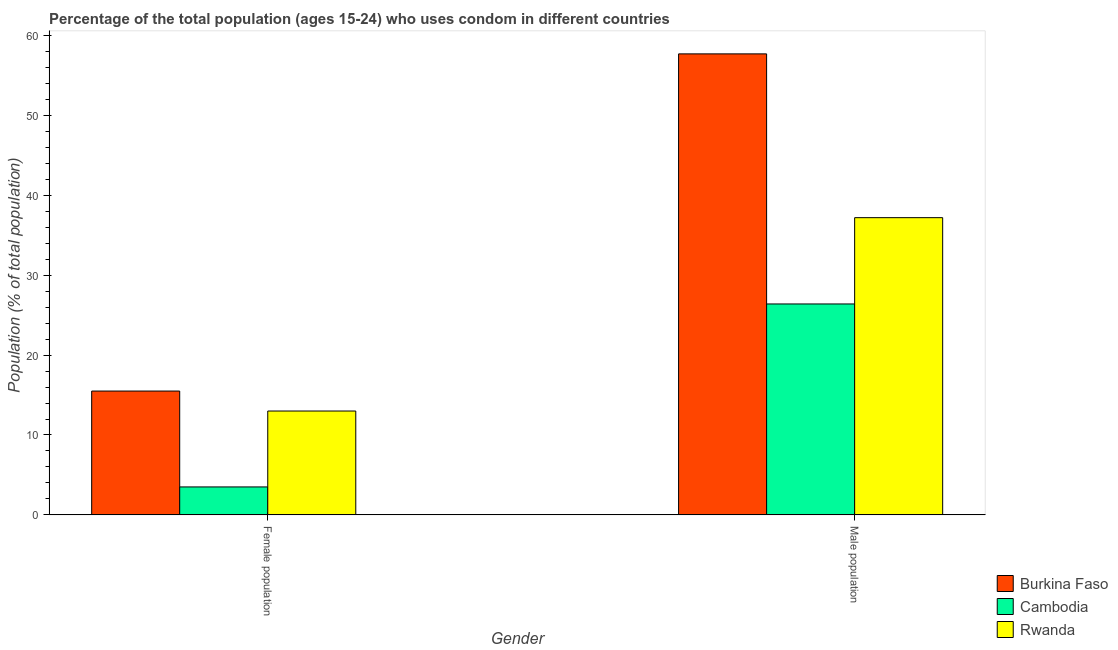How many different coloured bars are there?
Give a very brief answer. 3. How many groups of bars are there?
Provide a short and direct response. 2. Are the number of bars per tick equal to the number of legend labels?
Your response must be concise. Yes. How many bars are there on the 2nd tick from the left?
Your answer should be very brief. 3. What is the label of the 1st group of bars from the left?
Provide a succinct answer. Female population. What is the male population in Cambodia?
Provide a succinct answer. 26.4. Across all countries, what is the maximum male population?
Make the answer very short. 57.7. Across all countries, what is the minimum male population?
Ensure brevity in your answer.  26.4. In which country was the male population maximum?
Your answer should be very brief. Burkina Faso. In which country was the female population minimum?
Ensure brevity in your answer.  Cambodia. What is the total male population in the graph?
Offer a terse response. 121.3. What is the difference between the male population in Burkina Faso and that in Cambodia?
Your answer should be very brief. 31.3. What is the difference between the male population in Cambodia and the female population in Burkina Faso?
Your answer should be compact. 10.9. What is the average female population per country?
Give a very brief answer. 10.67. What is the difference between the female population and male population in Cambodia?
Give a very brief answer. -22.9. In how many countries, is the female population greater than 32 %?
Your answer should be very brief. 0. What is the ratio of the male population in Burkina Faso to that in Rwanda?
Keep it short and to the point. 1.55. In how many countries, is the male population greater than the average male population taken over all countries?
Give a very brief answer. 1. What does the 3rd bar from the left in Female population represents?
Keep it short and to the point. Rwanda. What does the 2nd bar from the right in Female population represents?
Give a very brief answer. Cambodia. How many bars are there?
Make the answer very short. 6. What is the difference between two consecutive major ticks on the Y-axis?
Offer a terse response. 10. Are the values on the major ticks of Y-axis written in scientific E-notation?
Your response must be concise. No. Where does the legend appear in the graph?
Offer a terse response. Bottom right. How are the legend labels stacked?
Make the answer very short. Vertical. What is the title of the graph?
Give a very brief answer. Percentage of the total population (ages 15-24) who uses condom in different countries. Does "Equatorial Guinea" appear as one of the legend labels in the graph?
Your answer should be very brief. No. What is the label or title of the X-axis?
Keep it short and to the point. Gender. What is the label or title of the Y-axis?
Provide a short and direct response. Population (% of total population) . What is the Population (% of total population)  in Burkina Faso in Male population?
Provide a succinct answer. 57.7. What is the Population (% of total population)  in Cambodia in Male population?
Ensure brevity in your answer.  26.4. What is the Population (% of total population)  in Rwanda in Male population?
Keep it short and to the point. 37.2. Across all Gender, what is the maximum Population (% of total population)  in Burkina Faso?
Give a very brief answer. 57.7. Across all Gender, what is the maximum Population (% of total population)  of Cambodia?
Make the answer very short. 26.4. Across all Gender, what is the maximum Population (% of total population)  in Rwanda?
Keep it short and to the point. 37.2. What is the total Population (% of total population)  in Burkina Faso in the graph?
Keep it short and to the point. 73.2. What is the total Population (% of total population)  in Cambodia in the graph?
Your answer should be very brief. 29.9. What is the total Population (% of total population)  of Rwanda in the graph?
Make the answer very short. 50.2. What is the difference between the Population (% of total population)  of Burkina Faso in Female population and that in Male population?
Keep it short and to the point. -42.2. What is the difference between the Population (% of total population)  in Cambodia in Female population and that in Male population?
Ensure brevity in your answer.  -22.9. What is the difference between the Population (% of total population)  of Rwanda in Female population and that in Male population?
Keep it short and to the point. -24.2. What is the difference between the Population (% of total population)  of Burkina Faso in Female population and the Population (% of total population)  of Cambodia in Male population?
Provide a short and direct response. -10.9. What is the difference between the Population (% of total population)  in Burkina Faso in Female population and the Population (% of total population)  in Rwanda in Male population?
Offer a terse response. -21.7. What is the difference between the Population (% of total population)  in Cambodia in Female population and the Population (% of total population)  in Rwanda in Male population?
Your response must be concise. -33.7. What is the average Population (% of total population)  of Burkina Faso per Gender?
Keep it short and to the point. 36.6. What is the average Population (% of total population)  in Cambodia per Gender?
Provide a succinct answer. 14.95. What is the average Population (% of total population)  in Rwanda per Gender?
Offer a very short reply. 25.1. What is the difference between the Population (% of total population)  of Burkina Faso and Population (% of total population)  of Rwanda in Female population?
Your response must be concise. 2.5. What is the difference between the Population (% of total population)  in Cambodia and Population (% of total population)  in Rwanda in Female population?
Provide a short and direct response. -9.5. What is the difference between the Population (% of total population)  of Burkina Faso and Population (% of total population)  of Cambodia in Male population?
Keep it short and to the point. 31.3. What is the ratio of the Population (% of total population)  in Burkina Faso in Female population to that in Male population?
Keep it short and to the point. 0.27. What is the ratio of the Population (% of total population)  in Cambodia in Female population to that in Male population?
Offer a very short reply. 0.13. What is the ratio of the Population (% of total population)  in Rwanda in Female population to that in Male population?
Offer a terse response. 0.35. What is the difference between the highest and the second highest Population (% of total population)  in Burkina Faso?
Your answer should be compact. 42.2. What is the difference between the highest and the second highest Population (% of total population)  of Cambodia?
Provide a succinct answer. 22.9. What is the difference between the highest and the second highest Population (% of total population)  in Rwanda?
Your response must be concise. 24.2. What is the difference between the highest and the lowest Population (% of total population)  in Burkina Faso?
Offer a very short reply. 42.2. What is the difference between the highest and the lowest Population (% of total population)  in Cambodia?
Make the answer very short. 22.9. What is the difference between the highest and the lowest Population (% of total population)  in Rwanda?
Make the answer very short. 24.2. 